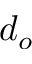Convert formula to latex. <formula><loc_0><loc_0><loc_500><loc_500>d _ { o }</formula> 